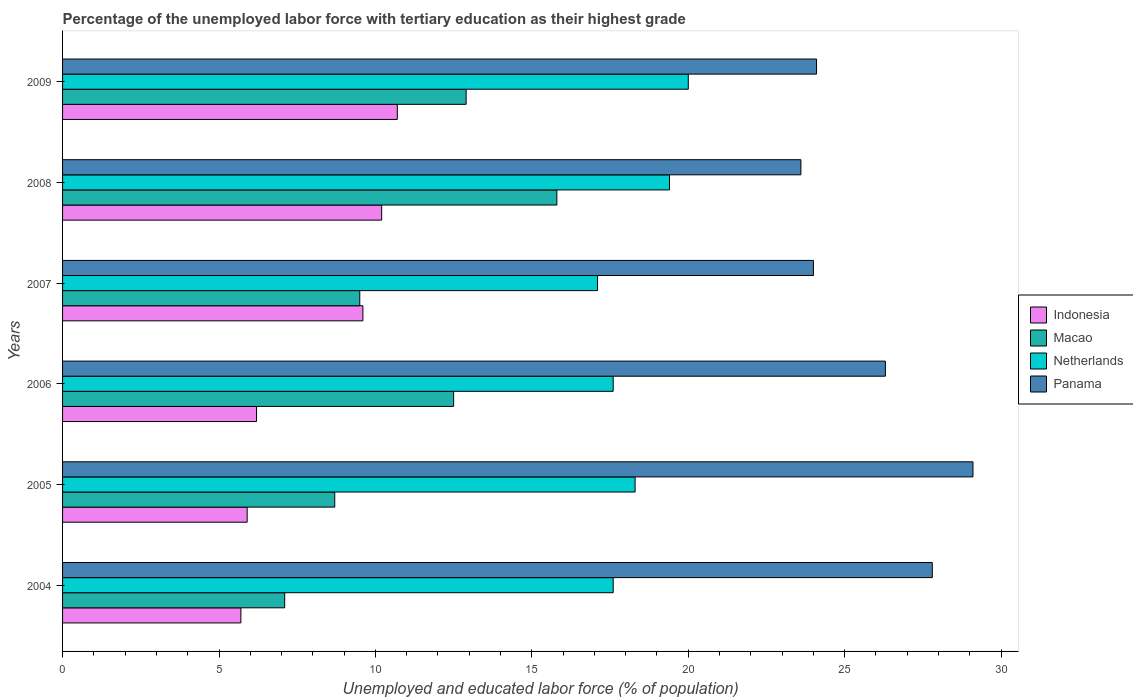Are the number of bars on each tick of the Y-axis equal?
Your answer should be very brief. Yes. How many bars are there on the 5th tick from the top?
Ensure brevity in your answer.  4. What is the label of the 4th group of bars from the top?
Keep it short and to the point. 2006. What is the percentage of the unemployed labor force with tertiary education in Indonesia in 2009?
Your response must be concise. 10.7. Across all years, what is the maximum percentage of the unemployed labor force with tertiary education in Macao?
Provide a short and direct response. 15.8. Across all years, what is the minimum percentage of the unemployed labor force with tertiary education in Netherlands?
Offer a very short reply. 17.1. In which year was the percentage of the unemployed labor force with tertiary education in Panama minimum?
Offer a terse response. 2008. What is the total percentage of the unemployed labor force with tertiary education in Macao in the graph?
Offer a terse response. 66.5. What is the difference between the percentage of the unemployed labor force with tertiary education in Indonesia in 2006 and that in 2008?
Keep it short and to the point. -4. What is the difference between the percentage of the unemployed labor force with tertiary education in Indonesia in 2005 and the percentage of the unemployed labor force with tertiary education in Macao in 2008?
Ensure brevity in your answer.  -9.9. What is the average percentage of the unemployed labor force with tertiary education in Panama per year?
Your answer should be compact. 25.82. In the year 2004, what is the difference between the percentage of the unemployed labor force with tertiary education in Panama and percentage of the unemployed labor force with tertiary education in Netherlands?
Keep it short and to the point. 10.2. What is the ratio of the percentage of the unemployed labor force with tertiary education in Netherlands in 2008 to that in 2009?
Your answer should be compact. 0.97. Is the percentage of the unemployed labor force with tertiary education in Indonesia in 2004 less than that in 2005?
Ensure brevity in your answer.  Yes. What is the difference between the highest and the second highest percentage of the unemployed labor force with tertiary education in Panama?
Ensure brevity in your answer.  1.3. What is the difference between the highest and the lowest percentage of the unemployed labor force with tertiary education in Panama?
Your answer should be very brief. 5.5. In how many years, is the percentage of the unemployed labor force with tertiary education in Netherlands greater than the average percentage of the unemployed labor force with tertiary education in Netherlands taken over all years?
Provide a succinct answer. 2. What does the 1st bar from the top in 2007 represents?
Make the answer very short. Panama. What does the 4th bar from the bottom in 2008 represents?
Your answer should be very brief. Panama. Is it the case that in every year, the sum of the percentage of the unemployed labor force with tertiary education in Panama and percentage of the unemployed labor force with tertiary education in Netherlands is greater than the percentage of the unemployed labor force with tertiary education in Indonesia?
Your answer should be compact. Yes. How many bars are there?
Make the answer very short. 24. Are all the bars in the graph horizontal?
Your answer should be very brief. Yes. How many years are there in the graph?
Ensure brevity in your answer.  6. What is the difference between two consecutive major ticks on the X-axis?
Offer a terse response. 5. How many legend labels are there?
Your answer should be compact. 4. What is the title of the graph?
Offer a terse response. Percentage of the unemployed labor force with tertiary education as their highest grade. What is the label or title of the X-axis?
Make the answer very short. Unemployed and educated labor force (% of population). What is the label or title of the Y-axis?
Ensure brevity in your answer.  Years. What is the Unemployed and educated labor force (% of population) in Indonesia in 2004?
Provide a short and direct response. 5.7. What is the Unemployed and educated labor force (% of population) in Macao in 2004?
Your response must be concise. 7.1. What is the Unemployed and educated labor force (% of population) of Netherlands in 2004?
Your answer should be compact. 17.6. What is the Unemployed and educated labor force (% of population) of Panama in 2004?
Your answer should be compact. 27.8. What is the Unemployed and educated labor force (% of population) of Indonesia in 2005?
Provide a short and direct response. 5.9. What is the Unemployed and educated labor force (% of population) in Macao in 2005?
Your response must be concise. 8.7. What is the Unemployed and educated labor force (% of population) in Netherlands in 2005?
Provide a short and direct response. 18.3. What is the Unemployed and educated labor force (% of population) of Panama in 2005?
Provide a short and direct response. 29.1. What is the Unemployed and educated labor force (% of population) of Indonesia in 2006?
Offer a terse response. 6.2. What is the Unemployed and educated labor force (% of population) of Netherlands in 2006?
Keep it short and to the point. 17.6. What is the Unemployed and educated labor force (% of population) in Panama in 2006?
Keep it short and to the point. 26.3. What is the Unemployed and educated labor force (% of population) of Indonesia in 2007?
Provide a succinct answer. 9.6. What is the Unemployed and educated labor force (% of population) of Macao in 2007?
Provide a succinct answer. 9.5. What is the Unemployed and educated labor force (% of population) in Netherlands in 2007?
Make the answer very short. 17.1. What is the Unemployed and educated labor force (% of population) of Panama in 2007?
Keep it short and to the point. 24. What is the Unemployed and educated labor force (% of population) of Indonesia in 2008?
Offer a very short reply. 10.2. What is the Unemployed and educated labor force (% of population) in Macao in 2008?
Provide a short and direct response. 15.8. What is the Unemployed and educated labor force (% of population) in Netherlands in 2008?
Offer a very short reply. 19.4. What is the Unemployed and educated labor force (% of population) of Panama in 2008?
Provide a short and direct response. 23.6. What is the Unemployed and educated labor force (% of population) of Indonesia in 2009?
Offer a very short reply. 10.7. What is the Unemployed and educated labor force (% of population) in Macao in 2009?
Your answer should be very brief. 12.9. What is the Unemployed and educated labor force (% of population) in Netherlands in 2009?
Provide a succinct answer. 20. What is the Unemployed and educated labor force (% of population) in Panama in 2009?
Offer a very short reply. 24.1. Across all years, what is the maximum Unemployed and educated labor force (% of population) in Indonesia?
Give a very brief answer. 10.7. Across all years, what is the maximum Unemployed and educated labor force (% of population) in Macao?
Your answer should be very brief. 15.8. Across all years, what is the maximum Unemployed and educated labor force (% of population) of Panama?
Offer a very short reply. 29.1. Across all years, what is the minimum Unemployed and educated labor force (% of population) of Indonesia?
Ensure brevity in your answer.  5.7. Across all years, what is the minimum Unemployed and educated labor force (% of population) of Macao?
Provide a succinct answer. 7.1. Across all years, what is the minimum Unemployed and educated labor force (% of population) in Netherlands?
Your response must be concise. 17.1. Across all years, what is the minimum Unemployed and educated labor force (% of population) of Panama?
Offer a very short reply. 23.6. What is the total Unemployed and educated labor force (% of population) in Indonesia in the graph?
Keep it short and to the point. 48.3. What is the total Unemployed and educated labor force (% of population) in Macao in the graph?
Provide a short and direct response. 66.5. What is the total Unemployed and educated labor force (% of population) in Netherlands in the graph?
Your answer should be very brief. 110. What is the total Unemployed and educated labor force (% of population) of Panama in the graph?
Your answer should be compact. 154.9. What is the difference between the Unemployed and educated labor force (% of population) of Indonesia in 2004 and that in 2005?
Your answer should be compact. -0.2. What is the difference between the Unemployed and educated labor force (% of population) of Netherlands in 2004 and that in 2005?
Your response must be concise. -0.7. What is the difference between the Unemployed and educated labor force (% of population) of Indonesia in 2004 and that in 2006?
Offer a terse response. -0.5. What is the difference between the Unemployed and educated labor force (% of population) in Macao in 2004 and that in 2006?
Offer a very short reply. -5.4. What is the difference between the Unemployed and educated labor force (% of population) in Netherlands in 2004 and that in 2006?
Make the answer very short. 0. What is the difference between the Unemployed and educated labor force (% of population) of Panama in 2004 and that in 2006?
Your response must be concise. 1.5. What is the difference between the Unemployed and educated labor force (% of population) in Netherlands in 2004 and that in 2007?
Provide a short and direct response. 0.5. What is the difference between the Unemployed and educated labor force (% of population) of Panama in 2004 and that in 2007?
Ensure brevity in your answer.  3.8. What is the difference between the Unemployed and educated labor force (% of population) of Indonesia in 2004 and that in 2008?
Your response must be concise. -4.5. What is the difference between the Unemployed and educated labor force (% of population) in Macao in 2004 and that in 2008?
Provide a succinct answer. -8.7. What is the difference between the Unemployed and educated labor force (% of population) in Netherlands in 2004 and that in 2008?
Provide a short and direct response. -1.8. What is the difference between the Unemployed and educated labor force (% of population) in Indonesia in 2004 and that in 2009?
Make the answer very short. -5. What is the difference between the Unemployed and educated labor force (% of population) of Macao in 2004 and that in 2009?
Make the answer very short. -5.8. What is the difference between the Unemployed and educated labor force (% of population) in Netherlands in 2005 and that in 2006?
Provide a short and direct response. 0.7. What is the difference between the Unemployed and educated labor force (% of population) of Indonesia in 2005 and that in 2007?
Provide a succinct answer. -3.7. What is the difference between the Unemployed and educated labor force (% of population) in Macao in 2005 and that in 2007?
Keep it short and to the point. -0.8. What is the difference between the Unemployed and educated labor force (% of population) of Netherlands in 2005 and that in 2007?
Ensure brevity in your answer.  1.2. What is the difference between the Unemployed and educated labor force (% of population) of Panama in 2005 and that in 2007?
Ensure brevity in your answer.  5.1. What is the difference between the Unemployed and educated labor force (% of population) of Indonesia in 2005 and that in 2008?
Your answer should be compact. -4.3. What is the difference between the Unemployed and educated labor force (% of population) of Macao in 2005 and that in 2008?
Offer a very short reply. -7.1. What is the difference between the Unemployed and educated labor force (% of population) in Netherlands in 2005 and that in 2008?
Offer a terse response. -1.1. What is the difference between the Unemployed and educated labor force (% of population) in Panama in 2005 and that in 2008?
Make the answer very short. 5.5. What is the difference between the Unemployed and educated labor force (% of population) of Indonesia in 2005 and that in 2009?
Your answer should be very brief. -4.8. What is the difference between the Unemployed and educated labor force (% of population) of Netherlands in 2005 and that in 2009?
Your answer should be very brief. -1.7. What is the difference between the Unemployed and educated labor force (% of population) of Panama in 2006 and that in 2007?
Make the answer very short. 2.3. What is the difference between the Unemployed and educated labor force (% of population) of Indonesia in 2006 and that in 2008?
Ensure brevity in your answer.  -4. What is the difference between the Unemployed and educated labor force (% of population) in Macao in 2006 and that in 2008?
Offer a very short reply. -3.3. What is the difference between the Unemployed and educated labor force (% of population) of Macao in 2007 and that in 2008?
Your response must be concise. -6.3. What is the difference between the Unemployed and educated labor force (% of population) of Indonesia in 2007 and that in 2009?
Provide a succinct answer. -1.1. What is the difference between the Unemployed and educated labor force (% of population) of Netherlands in 2007 and that in 2009?
Keep it short and to the point. -2.9. What is the difference between the Unemployed and educated labor force (% of population) in Indonesia in 2008 and that in 2009?
Provide a short and direct response. -0.5. What is the difference between the Unemployed and educated labor force (% of population) in Panama in 2008 and that in 2009?
Provide a succinct answer. -0.5. What is the difference between the Unemployed and educated labor force (% of population) in Indonesia in 2004 and the Unemployed and educated labor force (% of population) in Panama in 2005?
Keep it short and to the point. -23.4. What is the difference between the Unemployed and educated labor force (% of population) of Indonesia in 2004 and the Unemployed and educated labor force (% of population) of Netherlands in 2006?
Keep it short and to the point. -11.9. What is the difference between the Unemployed and educated labor force (% of population) of Indonesia in 2004 and the Unemployed and educated labor force (% of population) of Panama in 2006?
Provide a short and direct response. -20.6. What is the difference between the Unemployed and educated labor force (% of population) in Macao in 2004 and the Unemployed and educated labor force (% of population) in Panama in 2006?
Keep it short and to the point. -19.2. What is the difference between the Unemployed and educated labor force (% of population) in Indonesia in 2004 and the Unemployed and educated labor force (% of population) in Macao in 2007?
Provide a short and direct response. -3.8. What is the difference between the Unemployed and educated labor force (% of population) in Indonesia in 2004 and the Unemployed and educated labor force (% of population) in Netherlands in 2007?
Provide a succinct answer. -11.4. What is the difference between the Unemployed and educated labor force (% of population) of Indonesia in 2004 and the Unemployed and educated labor force (% of population) of Panama in 2007?
Offer a terse response. -18.3. What is the difference between the Unemployed and educated labor force (% of population) of Macao in 2004 and the Unemployed and educated labor force (% of population) of Netherlands in 2007?
Your answer should be very brief. -10. What is the difference between the Unemployed and educated labor force (% of population) of Macao in 2004 and the Unemployed and educated labor force (% of population) of Panama in 2007?
Offer a terse response. -16.9. What is the difference between the Unemployed and educated labor force (% of population) in Indonesia in 2004 and the Unemployed and educated labor force (% of population) in Netherlands in 2008?
Make the answer very short. -13.7. What is the difference between the Unemployed and educated labor force (% of population) in Indonesia in 2004 and the Unemployed and educated labor force (% of population) in Panama in 2008?
Provide a succinct answer. -17.9. What is the difference between the Unemployed and educated labor force (% of population) of Macao in 2004 and the Unemployed and educated labor force (% of population) of Panama in 2008?
Provide a succinct answer. -16.5. What is the difference between the Unemployed and educated labor force (% of population) of Indonesia in 2004 and the Unemployed and educated labor force (% of population) of Netherlands in 2009?
Offer a very short reply. -14.3. What is the difference between the Unemployed and educated labor force (% of population) of Indonesia in 2004 and the Unemployed and educated labor force (% of population) of Panama in 2009?
Offer a terse response. -18.4. What is the difference between the Unemployed and educated labor force (% of population) of Macao in 2004 and the Unemployed and educated labor force (% of population) of Panama in 2009?
Give a very brief answer. -17. What is the difference between the Unemployed and educated labor force (% of population) in Indonesia in 2005 and the Unemployed and educated labor force (% of population) in Macao in 2006?
Provide a succinct answer. -6.6. What is the difference between the Unemployed and educated labor force (% of population) in Indonesia in 2005 and the Unemployed and educated labor force (% of population) in Panama in 2006?
Your response must be concise. -20.4. What is the difference between the Unemployed and educated labor force (% of population) in Macao in 2005 and the Unemployed and educated labor force (% of population) in Panama in 2006?
Offer a very short reply. -17.6. What is the difference between the Unemployed and educated labor force (% of population) of Netherlands in 2005 and the Unemployed and educated labor force (% of population) of Panama in 2006?
Provide a short and direct response. -8. What is the difference between the Unemployed and educated labor force (% of population) of Indonesia in 2005 and the Unemployed and educated labor force (% of population) of Netherlands in 2007?
Offer a very short reply. -11.2. What is the difference between the Unemployed and educated labor force (% of population) in Indonesia in 2005 and the Unemployed and educated labor force (% of population) in Panama in 2007?
Provide a succinct answer. -18.1. What is the difference between the Unemployed and educated labor force (% of population) in Macao in 2005 and the Unemployed and educated labor force (% of population) in Netherlands in 2007?
Provide a succinct answer. -8.4. What is the difference between the Unemployed and educated labor force (% of population) of Macao in 2005 and the Unemployed and educated labor force (% of population) of Panama in 2007?
Your answer should be compact. -15.3. What is the difference between the Unemployed and educated labor force (% of population) of Indonesia in 2005 and the Unemployed and educated labor force (% of population) of Macao in 2008?
Ensure brevity in your answer.  -9.9. What is the difference between the Unemployed and educated labor force (% of population) of Indonesia in 2005 and the Unemployed and educated labor force (% of population) of Netherlands in 2008?
Offer a very short reply. -13.5. What is the difference between the Unemployed and educated labor force (% of population) of Indonesia in 2005 and the Unemployed and educated labor force (% of population) of Panama in 2008?
Your answer should be compact. -17.7. What is the difference between the Unemployed and educated labor force (% of population) of Macao in 2005 and the Unemployed and educated labor force (% of population) of Panama in 2008?
Give a very brief answer. -14.9. What is the difference between the Unemployed and educated labor force (% of population) in Indonesia in 2005 and the Unemployed and educated labor force (% of population) in Macao in 2009?
Your answer should be compact. -7. What is the difference between the Unemployed and educated labor force (% of population) of Indonesia in 2005 and the Unemployed and educated labor force (% of population) of Netherlands in 2009?
Give a very brief answer. -14.1. What is the difference between the Unemployed and educated labor force (% of population) in Indonesia in 2005 and the Unemployed and educated labor force (% of population) in Panama in 2009?
Your answer should be compact. -18.2. What is the difference between the Unemployed and educated labor force (% of population) in Macao in 2005 and the Unemployed and educated labor force (% of population) in Panama in 2009?
Provide a short and direct response. -15.4. What is the difference between the Unemployed and educated labor force (% of population) of Indonesia in 2006 and the Unemployed and educated labor force (% of population) of Netherlands in 2007?
Your response must be concise. -10.9. What is the difference between the Unemployed and educated labor force (% of population) of Indonesia in 2006 and the Unemployed and educated labor force (% of population) of Panama in 2007?
Give a very brief answer. -17.8. What is the difference between the Unemployed and educated labor force (% of population) of Macao in 2006 and the Unemployed and educated labor force (% of population) of Netherlands in 2007?
Make the answer very short. -4.6. What is the difference between the Unemployed and educated labor force (% of population) in Macao in 2006 and the Unemployed and educated labor force (% of population) in Panama in 2007?
Give a very brief answer. -11.5. What is the difference between the Unemployed and educated labor force (% of population) in Indonesia in 2006 and the Unemployed and educated labor force (% of population) in Macao in 2008?
Provide a succinct answer. -9.6. What is the difference between the Unemployed and educated labor force (% of population) in Indonesia in 2006 and the Unemployed and educated labor force (% of population) in Netherlands in 2008?
Your response must be concise. -13.2. What is the difference between the Unemployed and educated labor force (% of population) in Indonesia in 2006 and the Unemployed and educated labor force (% of population) in Panama in 2008?
Make the answer very short. -17.4. What is the difference between the Unemployed and educated labor force (% of population) of Netherlands in 2006 and the Unemployed and educated labor force (% of population) of Panama in 2008?
Provide a succinct answer. -6. What is the difference between the Unemployed and educated labor force (% of population) of Indonesia in 2006 and the Unemployed and educated labor force (% of population) of Netherlands in 2009?
Your answer should be compact. -13.8. What is the difference between the Unemployed and educated labor force (% of population) in Indonesia in 2006 and the Unemployed and educated labor force (% of population) in Panama in 2009?
Your answer should be compact. -17.9. What is the difference between the Unemployed and educated labor force (% of population) in Macao in 2006 and the Unemployed and educated labor force (% of population) in Panama in 2009?
Offer a terse response. -11.6. What is the difference between the Unemployed and educated labor force (% of population) of Netherlands in 2006 and the Unemployed and educated labor force (% of population) of Panama in 2009?
Keep it short and to the point. -6.5. What is the difference between the Unemployed and educated labor force (% of population) in Indonesia in 2007 and the Unemployed and educated labor force (% of population) in Netherlands in 2008?
Give a very brief answer. -9.8. What is the difference between the Unemployed and educated labor force (% of population) in Indonesia in 2007 and the Unemployed and educated labor force (% of population) in Panama in 2008?
Offer a very short reply. -14. What is the difference between the Unemployed and educated labor force (% of population) in Macao in 2007 and the Unemployed and educated labor force (% of population) in Panama in 2008?
Offer a very short reply. -14.1. What is the difference between the Unemployed and educated labor force (% of population) in Indonesia in 2007 and the Unemployed and educated labor force (% of population) in Macao in 2009?
Provide a succinct answer. -3.3. What is the difference between the Unemployed and educated labor force (% of population) of Macao in 2007 and the Unemployed and educated labor force (% of population) of Panama in 2009?
Keep it short and to the point. -14.6. What is the difference between the Unemployed and educated labor force (% of population) in Indonesia in 2008 and the Unemployed and educated labor force (% of population) in Panama in 2009?
Make the answer very short. -13.9. What is the difference between the Unemployed and educated labor force (% of population) of Macao in 2008 and the Unemployed and educated labor force (% of population) of Netherlands in 2009?
Your response must be concise. -4.2. What is the difference between the Unemployed and educated labor force (% of population) in Netherlands in 2008 and the Unemployed and educated labor force (% of population) in Panama in 2009?
Give a very brief answer. -4.7. What is the average Unemployed and educated labor force (% of population) of Indonesia per year?
Your response must be concise. 8.05. What is the average Unemployed and educated labor force (% of population) of Macao per year?
Your response must be concise. 11.08. What is the average Unemployed and educated labor force (% of population) of Netherlands per year?
Your answer should be compact. 18.33. What is the average Unemployed and educated labor force (% of population) in Panama per year?
Keep it short and to the point. 25.82. In the year 2004, what is the difference between the Unemployed and educated labor force (% of population) in Indonesia and Unemployed and educated labor force (% of population) in Panama?
Offer a very short reply. -22.1. In the year 2004, what is the difference between the Unemployed and educated labor force (% of population) in Macao and Unemployed and educated labor force (% of population) in Netherlands?
Make the answer very short. -10.5. In the year 2004, what is the difference between the Unemployed and educated labor force (% of population) in Macao and Unemployed and educated labor force (% of population) in Panama?
Offer a very short reply. -20.7. In the year 2005, what is the difference between the Unemployed and educated labor force (% of population) of Indonesia and Unemployed and educated labor force (% of population) of Macao?
Ensure brevity in your answer.  -2.8. In the year 2005, what is the difference between the Unemployed and educated labor force (% of population) in Indonesia and Unemployed and educated labor force (% of population) in Netherlands?
Ensure brevity in your answer.  -12.4. In the year 2005, what is the difference between the Unemployed and educated labor force (% of population) in Indonesia and Unemployed and educated labor force (% of population) in Panama?
Provide a succinct answer. -23.2. In the year 2005, what is the difference between the Unemployed and educated labor force (% of population) of Macao and Unemployed and educated labor force (% of population) of Netherlands?
Offer a terse response. -9.6. In the year 2005, what is the difference between the Unemployed and educated labor force (% of population) of Macao and Unemployed and educated labor force (% of population) of Panama?
Offer a terse response. -20.4. In the year 2005, what is the difference between the Unemployed and educated labor force (% of population) of Netherlands and Unemployed and educated labor force (% of population) of Panama?
Ensure brevity in your answer.  -10.8. In the year 2006, what is the difference between the Unemployed and educated labor force (% of population) of Indonesia and Unemployed and educated labor force (% of population) of Macao?
Give a very brief answer. -6.3. In the year 2006, what is the difference between the Unemployed and educated labor force (% of population) of Indonesia and Unemployed and educated labor force (% of population) of Netherlands?
Ensure brevity in your answer.  -11.4. In the year 2006, what is the difference between the Unemployed and educated labor force (% of population) of Indonesia and Unemployed and educated labor force (% of population) of Panama?
Your response must be concise. -20.1. In the year 2006, what is the difference between the Unemployed and educated labor force (% of population) of Macao and Unemployed and educated labor force (% of population) of Netherlands?
Provide a short and direct response. -5.1. In the year 2006, what is the difference between the Unemployed and educated labor force (% of population) in Netherlands and Unemployed and educated labor force (% of population) in Panama?
Provide a succinct answer. -8.7. In the year 2007, what is the difference between the Unemployed and educated labor force (% of population) of Indonesia and Unemployed and educated labor force (% of population) of Macao?
Give a very brief answer. 0.1. In the year 2007, what is the difference between the Unemployed and educated labor force (% of population) of Indonesia and Unemployed and educated labor force (% of population) of Panama?
Offer a terse response. -14.4. In the year 2007, what is the difference between the Unemployed and educated labor force (% of population) in Netherlands and Unemployed and educated labor force (% of population) in Panama?
Your answer should be compact. -6.9. In the year 2008, what is the difference between the Unemployed and educated labor force (% of population) of Indonesia and Unemployed and educated labor force (% of population) of Macao?
Offer a terse response. -5.6. In the year 2008, what is the difference between the Unemployed and educated labor force (% of population) of Indonesia and Unemployed and educated labor force (% of population) of Panama?
Make the answer very short. -13.4. In the year 2008, what is the difference between the Unemployed and educated labor force (% of population) in Macao and Unemployed and educated labor force (% of population) in Panama?
Ensure brevity in your answer.  -7.8. In the year 2008, what is the difference between the Unemployed and educated labor force (% of population) in Netherlands and Unemployed and educated labor force (% of population) in Panama?
Offer a very short reply. -4.2. In the year 2009, what is the difference between the Unemployed and educated labor force (% of population) of Macao and Unemployed and educated labor force (% of population) of Netherlands?
Make the answer very short. -7.1. In the year 2009, what is the difference between the Unemployed and educated labor force (% of population) of Netherlands and Unemployed and educated labor force (% of population) of Panama?
Give a very brief answer. -4.1. What is the ratio of the Unemployed and educated labor force (% of population) of Indonesia in 2004 to that in 2005?
Ensure brevity in your answer.  0.97. What is the ratio of the Unemployed and educated labor force (% of population) in Macao in 2004 to that in 2005?
Your answer should be very brief. 0.82. What is the ratio of the Unemployed and educated labor force (% of population) in Netherlands in 2004 to that in 2005?
Keep it short and to the point. 0.96. What is the ratio of the Unemployed and educated labor force (% of population) in Panama in 2004 to that in 2005?
Ensure brevity in your answer.  0.96. What is the ratio of the Unemployed and educated labor force (% of population) in Indonesia in 2004 to that in 2006?
Ensure brevity in your answer.  0.92. What is the ratio of the Unemployed and educated labor force (% of population) in Macao in 2004 to that in 2006?
Offer a terse response. 0.57. What is the ratio of the Unemployed and educated labor force (% of population) in Panama in 2004 to that in 2006?
Your answer should be very brief. 1.06. What is the ratio of the Unemployed and educated labor force (% of population) of Indonesia in 2004 to that in 2007?
Keep it short and to the point. 0.59. What is the ratio of the Unemployed and educated labor force (% of population) of Macao in 2004 to that in 2007?
Your answer should be compact. 0.75. What is the ratio of the Unemployed and educated labor force (% of population) in Netherlands in 2004 to that in 2007?
Make the answer very short. 1.03. What is the ratio of the Unemployed and educated labor force (% of population) in Panama in 2004 to that in 2007?
Make the answer very short. 1.16. What is the ratio of the Unemployed and educated labor force (% of population) of Indonesia in 2004 to that in 2008?
Your answer should be very brief. 0.56. What is the ratio of the Unemployed and educated labor force (% of population) in Macao in 2004 to that in 2008?
Your answer should be compact. 0.45. What is the ratio of the Unemployed and educated labor force (% of population) in Netherlands in 2004 to that in 2008?
Your answer should be very brief. 0.91. What is the ratio of the Unemployed and educated labor force (% of population) of Panama in 2004 to that in 2008?
Ensure brevity in your answer.  1.18. What is the ratio of the Unemployed and educated labor force (% of population) in Indonesia in 2004 to that in 2009?
Offer a very short reply. 0.53. What is the ratio of the Unemployed and educated labor force (% of population) in Macao in 2004 to that in 2009?
Your answer should be very brief. 0.55. What is the ratio of the Unemployed and educated labor force (% of population) of Panama in 2004 to that in 2009?
Offer a terse response. 1.15. What is the ratio of the Unemployed and educated labor force (% of population) of Indonesia in 2005 to that in 2006?
Offer a very short reply. 0.95. What is the ratio of the Unemployed and educated labor force (% of population) of Macao in 2005 to that in 2006?
Offer a very short reply. 0.7. What is the ratio of the Unemployed and educated labor force (% of population) of Netherlands in 2005 to that in 2006?
Keep it short and to the point. 1.04. What is the ratio of the Unemployed and educated labor force (% of population) of Panama in 2005 to that in 2006?
Give a very brief answer. 1.11. What is the ratio of the Unemployed and educated labor force (% of population) in Indonesia in 2005 to that in 2007?
Your answer should be very brief. 0.61. What is the ratio of the Unemployed and educated labor force (% of population) of Macao in 2005 to that in 2007?
Offer a very short reply. 0.92. What is the ratio of the Unemployed and educated labor force (% of population) of Netherlands in 2005 to that in 2007?
Your answer should be very brief. 1.07. What is the ratio of the Unemployed and educated labor force (% of population) in Panama in 2005 to that in 2007?
Keep it short and to the point. 1.21. What is the ratio of the Unemployed and educated labor force (% of population) in Indonesia in 2005 to that in 2008?
Provide a succinct answer. 0.58. What is the ratio of the Unemployed and educated labor force (% of population) in Macao in 2005 to that in 2008?
Offer a terse response. 0.55. What is the ratio of the Unemployed and educated labor force (% of population) of Netherlands in 2005 to that in 2008?
Provide a short and direct response. 0.94. What is the ratio of the Unemployed and educated labor force (% of population) in Panama in 2005 to that in 2008?
Your answer should be compact. 1.23. What is the ratio of the Unemployed and educated labor force (% of population) of Indonesia in 2005 to that in 2009?
Your response must be concise. 0.55. What is the ratio of the Unemployed and educated labor force (% of population) in Macao in 2005 to that in 2009?
Provide a succinct answer. 0.67. What is the ratio of the Unemployed and educated labor force (% of population) in Netherlands in 2005 to that in 2009?
Offer a terse response. 0.92. What is the ratio of the Unemployed and educated labor force (% of population) of Panama in 2005 to that in 2009?
Your answer should be very brief. 1.21. What is the ratio of the Unemployed and educated labor force (% of population) of Indonesia in 2006 to that in 2007?
Ensure brevity in your answer.  0.65. What is the ratio of the Unemployed and educated labor force (% of population) of Macao in 2006 to that in 2007?
Your answer should be compact. 1.32. What is the ratio of the Unemployed and educated labor force (% of population) in Netherlands in 2006 to that in 2007?
Ensure brevity in your answer.  1.03. What is the ratio of the Unemployed and educated labor force (% of population) of Panama in 2006 to that in 2007?
Give a very brief answer. 1.1. What is the ratio of the Unemployed and educated labor force (% of population) in Indonesia in 2006 to that in 2008?
Offer a terse response. 0.61. What is the ratio of the Unemployed and educated labor force (% of population) in Macao in 2006 to that in 2008?
Provide a succinct answer. 0.79. What is the ratio of the Unemployed and educated labor force (% of population) of Netherlands in 2006 to that in 2008?
Your answer should be very brief. 0.91. What is the ratio of the Unemployed and educated labor force (% of population) in Panama in 2006 to that in 2008?
Ensure brevity in your answer.  1.11. What is the ratio of the Unemployed and educated labor force (% of population) in Indonesia in 2006 to that in 2009?
Give a very brief answer. 0.58. What is the ratio of the Unemployed and educated labor force (% of population) of Macao in 2006 to that in 2009?
Your answer should be compact. 0.97. What is the ratio of the Unemployed and educated labor force (% of population) in Panama in 2006 to that in 2009?
Your response must be concise. 1.09. What is the ratio of the Unemployed and educated labor force (% of population) in Macao in 2007 to that in 2008?
Ensure brevity in your answer.  0.6. What is the ratio of the Unemployed and educated labor force (% of population) in Netherlands in 2007 to that in 2008?
Your answer should be very brief. 0.88. What is the ratio of the Unemployed and educated labor force (% of population) of Panama in 2007 to that in 2008?
Offer a very short reply. 1.02. What is the ratio of the Unemployed and educated labor force (% of population) in Indonesia in 2007 to that in 2009?
Offer a terse response. 0.9. What is the ratio of the Unemployed and educated labor force (% of population) in Macao in 2007 to that in 2009?
Your answer should be very brief. 0.74. What is the ratio of the Unemployed and educated labor force (% of population) of Netherlands in 2007 to that in 2009?
Your response must be concise. 0.85. What is the ratio of the Unemployed and educated labor force (% of population) of Panama in 2007 to that in 2009?
Provide a succinct answer. 1. What is the ratio of the Unemployed and educated labor force (% of population) of Indonesia in 2008 to that in 2009?
Make the answer very short. 0.95. What is the ratio of the Unemployed and educated labor force (% of population) in Macao in 2008 to that in 2009?
Your answer should be very brief. 1.22. What is the ratio of the Unemployed and educated labor force (% of population) in Panama in 2008 to that in 2009?
Your answer should be compact. 0.98. What is the difference between the highest and the second highest Unemployed and educated labor force (% of population) of Indonesia?
Keep it short and to the point. 0.5. What is the difference between the highest and the second highest Unemployed and educated labor force (% of population) of Macao?
Offer a very short reply. 2.9. What is the difference between the highest and the second highest Unemployed and educated labor force (% of population) of Netherlands?
Ensure brevity in your answer.  0.6. What is the difference between the highest and the lowest Unemployed and educated labor force (% of population) in Indonesia?
Ensure brevity in your answer.  5. What is the difference between the highest and the lowest Unemployed and educated labor force (% of population) of Macao?
Your answer should be very brief. 8.7. 